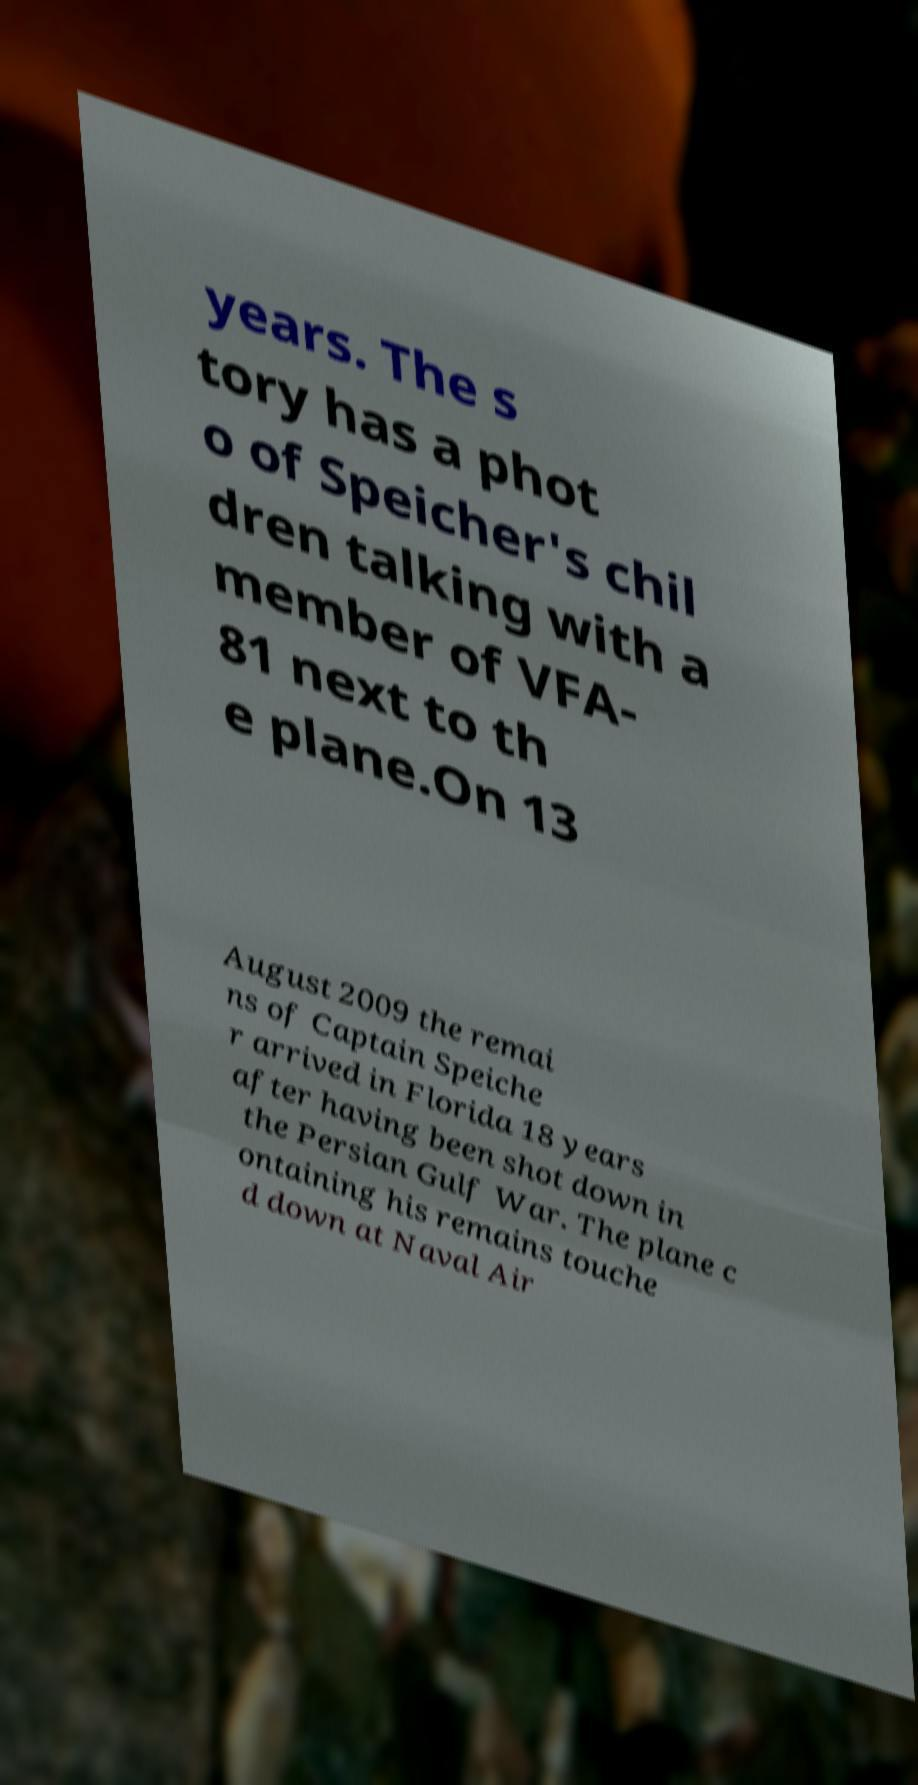There's text embedded in this image that I need extracted. Can you transcribe it verbatim? years. The s tory has a phot o of Speicher's chil dren talking with a member of VFA- 81 next to th e plane.On 13 August 2009 the remai ns of Captain Speiche r arrived in Florida 18 years after having been shot down in the Persian Gulf War. The plane c ontaining his remains touche d down at Naval Air 